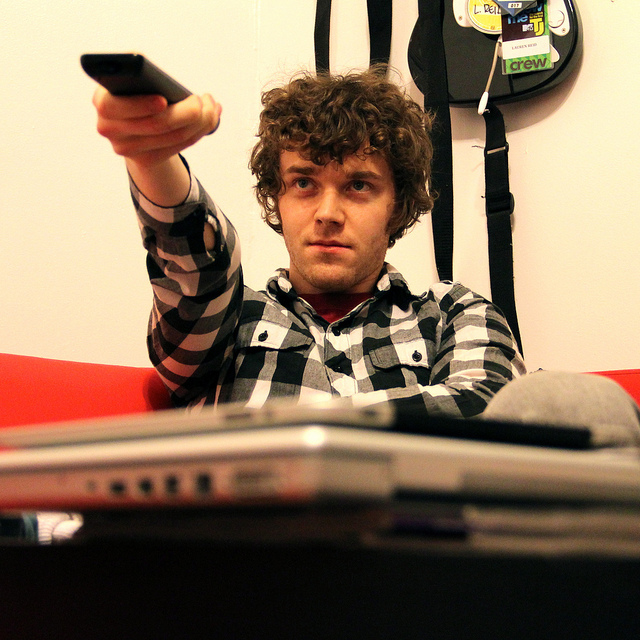Please extract the text content from this image. TJ me crew 